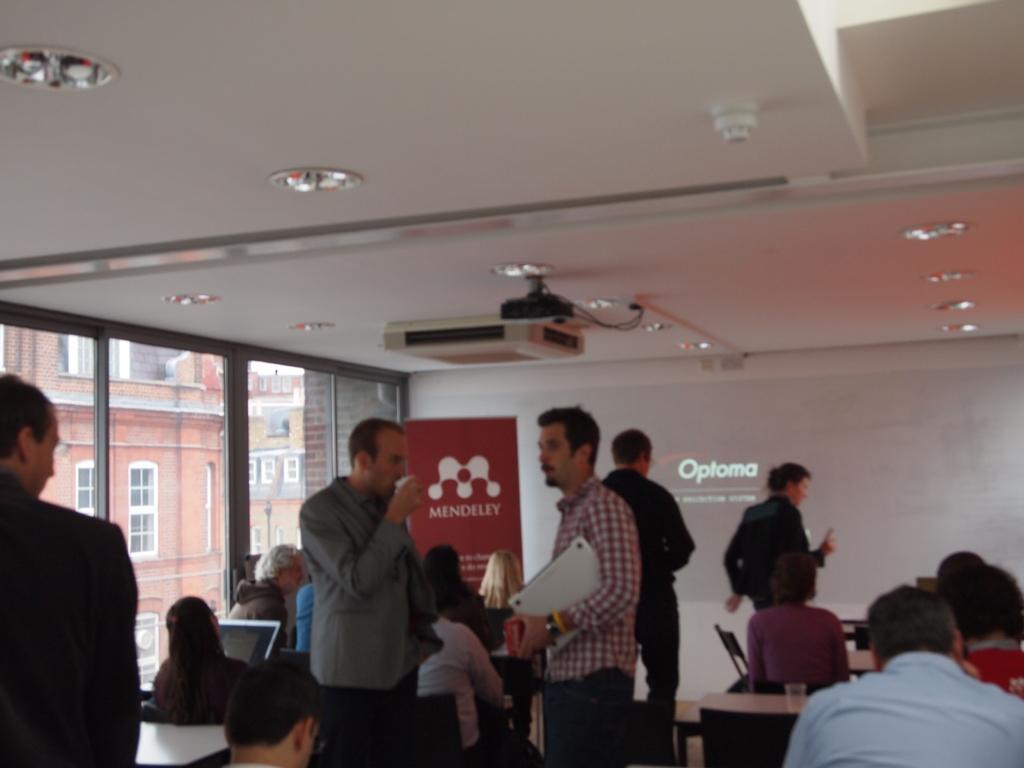Could you give a brief overview of what you see in this image? In this picture I can sew few people standing and few are seated and I can see glass on the table and a laptop and I can see an advertisement hoarding on the left with some text and I can see a projector and projector light displaying on the wall and few lights on the ceiling and from the glass, I can see buildings. 